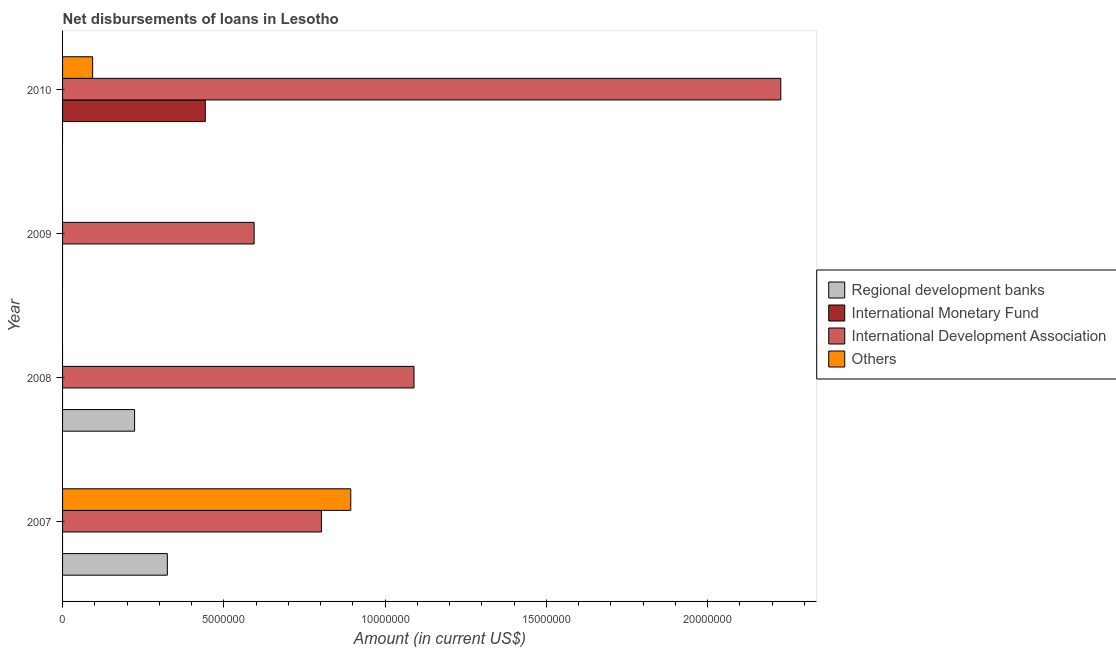How many different coloured bars are there?
Your response must be concise. 4. Are the number of bars per tick equal to the number of legend labels?
Make the answer very short. No. Are the number of bars on each tick of the Y-axis equal?
Offer a very short reply. No. How many bars are there on the 1st tick from the bottom?
Your answer should be very brief. 3. What is the amount of loan disimbursed by international development association in 2008?
Offer a very short reply. 1.09e+07. Across all years, what is the maximum amount of loan disimbursed by regional development banks?
Your answer should be compact. 3.25e+06. In which year was the amount of loan disimbursed by other organisations maximum?
Give a very brief answer. 2007. What is the total amount of loan disimbursed by regional development banks in the graph?
Offer a very short reply. 5.48e+06. What is the difference between the amount of loan disimbursed by international development association in 2007 and that in 2010?
Provide a short and direct response. -1.42e+07. What is the difference between the amount of loan disimbursed by international monetary fund in 2008 and the amount of loan disimbursed by regional development banks in 2007?
Your response must be concise. -3.25e+06. What is the average amount of loan disimbursed by other organisations per year?
Your answer should be compact. 2.47e+06. In the year 2010, what is the difference between the amount of loan disimbursed by international development association and amount of loan disimbursed by other organisations?
Give a very brief answer. 2.13e+07. What is the difference between the highest and the second highest amount of loan disimbursed by international development association?
Your answer should be compact. 1.14e+07. What is the difference between the highest and the lowest amount of loan disimbursed by other organisations?
Your response must be concise. 8.94e+06. Is it the case that in every year, the sum of the amount of loan disimbursed by international monetary fund and amount of loan disimbursed by regional development banks is greater than the sum of amount of loan disimbursed by international development association and amount of loan disimbursed by other organisations?
Keep it short and to the point. No. How many years are there in the graph?
Your answer should be compact. 4. Does the graph contain any zero values?
Make the answer very short. Yes. Does the graph contain grids?
Keep it short and to the point. No. How many legend labels are there?
Provide a short and direct response. 4. What is the title of the graph?
Your answer should be compact. Net disbursements of loans in Lesotho. Does "Negligence towards children" appear as one of the legend labels in the graph?
Make the answer very short. No. What is the Amount (in current US$) of Regional development banks in 2007?
Offer a very short reply. 3.25e+06. What is the Amount (in current US$) in International Monetary Fund in 2007?
Keep it short and to the point. 0. What is the Amount (in current US$) in International Development Association in 2007?
Ensure brevity in your answer.  8.02e+06. What is the Amount (in current US$) in Others in 2007?
Your response must be concise. 8.94e+06. What is the Amount (in current US$) in Regional development banks in 2008?
Offer a very short reply. 2.23e+06. What is the Amount (in current US$) in International Development Association in 2008?
Offer a terse response. 1.09e+07. What is the Amount (in current US$) in Regional development banks in 2009?
Your answer should be compact. 0. What is the Amount (in current US$) of International Development Association in 2009?
Provide a short and direct response. 5.94e+06. What is the Amount (in current US$) in Regional development banks in 2010?
Keep it short and to the point. 0. What is the Amount (in current US$) of International Monetary Fund in 2010?
Ensure brevity in your answer.  4.42e+06. What is the Amount (in current US$) in International Development Association in 2010?
Provide a succinct answer. 2.23e+07. What is the Amount (in current US$) in Others in 2010?
Your response must be concise. 9.32e+05. Across all years, what is the maximum Amount (in current US$) of Regional development banks?
Your answer should be compact. 3.25e+06. Across all years, what is the maximum Amount (in current US$) in International Monetary Fund?
Your response must be concise. 4.42e+06. Across all years, what is the maximum Amount (in current US$) in International Development Association?
Offer a very short reply. 2.23e+07. Across all years, what is the maximum Amount (in current US$) of Others?
Give a very brief answer. 8.94e+06. Across all years, what is the minimum Amount (in current US$) in Regional development banks?
Give a very brief answer. 0. Across all years, what is the minimum Amount (in current US$) in International Monetary Fund?
Offer a terse response. 0. Across all years, what is the minimum Amount (in current US$) of International Development Association?
Provide a succinct answer. 5.94e+06. What is the total Amount (in current US$) in Regional development banks in the graph?
Provide a short and direct response. 5.48e+06. What is the total Amount (in current US$) in International Monetary Fund in the graph?
Your answer should be compact. 4.42e+06. What is the total Amount (in current US$) of International Development Association in the graph?
Your answer should be compact. 4.71e+07. What is the total Amount (in current US$) of Others in the graph?
Offer a very short reply. 9.87e+06. What is the difference between the Amount (in current US$) in Regional development banks in 2007 and that in 2008?
Provide a succinct answer. 1.02e+06. What is the difference between the Amount (in current US$) of International Development Association in 2007 and that in 2008?
Provide a succinct answer. -2.87e+06. What is the difference between the Amount (in current US$) of International Development Association in 2007 and that in 2009?
Give a very brief answer. 2.09e+06. What is the difference between the Amount (in current US$) of International Development Association in 2007 and that in 2010?
Your answer should be very brief. -1.42e+07. What is the difference between the Amount (in current US$) in Others in 2007 and that in 2010?
Offer a very short reply. 8.00e+06. What is the difference between the Amount (in current US$) in International Development Association in 2008 and that in 2009?
Make the answer very short. 4.96e+06. What is the difference between the Amount (in current US$) in International Development Association in 2008 and that in 2010?
Give a very brief answer. -1.14e+07. What is the difference between the Amount (in current US$) in International Development Association in 2009 and that in 2010?
Ensure brevity in your answer.  -1.63e+07. What is the difference between the Amount (in current US$) in Regional development banks in 2007 and the Amount (in current US$) in International Development Association in 2008?
Offer a terse response. -7.65e+06. What is the difference between the Amount (in current US$) in Regional development banks in 2007 and the Amount (in current US$) in International Development Association in 2009?
Your answer should be very brief. -2.69e+06. What is the difference between the Amount (in current US$) of Regional development banks in 2007 and the Amount (in current US$) of International Monetary Fund in 2010?
Keep it short and to the point. -1.18e+06. What is the difference between the Amount (in current US$) in Regional development banks in 2007 and the Amount (in current US$) in International Development Association in 2010?
Your answer should be compact. -1.90e+07. What is the difference between the Amount (in current US$) of Regional development banks in 2007 and the Amount (in current US$) of Others in 2010?
Your answer should be compact. 2.32e+06. What is the difference between the Amount (in current US$) in International Development Association in 2007 and the Amount (in current US$) in Others in 2010?
Make the answer very short. 7.09e+06. What is the difference between the Amount (in current US$) in Regional development banks in 2008 and the Amount (in current US$) in International Development Association in 2009?
Your response must be concise. -3.71e+06. What is the difference between the Amount (in current US$) in Regional development banks in 2008 and the Amount (in current US$) in International Monetary Fund in 2010?
Your response must be concise. -2.19e+06. What is the difference between the Amount (in current US$) of Regional development banks in 2008 and the Amount (in current US$) of International Development Association in 2010?
Provide a succinct answer. -2.00e+07. What is the difference between the Amount (in current US$) in Regional development banks in 2008 and the Amount (in current US$) in Others in 2010?
Provide a short and direct response. 1.30e+06. What is the difference between the Amount (in current US$) in International Development Association in 2008 and the Amount (in current US$) in Others in 2010?
Your answer should be very brief. 9.96e+06. What is the difference between the Amount (in current US$) of International Development Association in 2009 and the Amount (in current US$) of Others in 2010?
Make the answer very short. 5.01e+06. What is the average Amount (in current US$) in Regional development banks per year?
Give a very brief answer. 1.37e+06. What is the average Amount (in current US$) of International Monetary Fund per year?
Your response must be concise. 1.11e+06. What is the average Amount (in current US$) in International Development Association per year?
Your answer should be very brief. 1.18e+07. What is the average Amount (in current US$) of Others per year?
Provide a succinct answer. 2.47e+06. In the year 2007, what is the difference between the Amount (in current US$) of Regional development banks and Amount (in current US$) of International Development Association?
Your answer should be very brief. -4.78e+06. In the year 2007, what is the difference between the Amount (in current US$) of Regional development banks and Amount (in current US$) of Others?
Your answer should be compact. -5.69e+06. In the year 2007, what is the difference between the Amount (in current US$) in International Development Association and Amount (in current US$) in Others?
Keep it short and to the point. -9.10e+05. In the year 2008, what is the difference between the Amount (in current US$) in Regional development banks and Amount (in current US$) in International Development Association?
Provide a short and direct response. -8.66e+06. In the year 2010, what is the difference between the Amount (in current US$) of International Monetary Fund and Amount (in current US$) of International Development Association?
Offer a very short reply. -1.78e+07. In the year 2010, what is the difference between the Amount (in current US$) in International Monetary Fund and Amount (in current US$) in Others?
Your response must be concise. 3.49e+06. In the year 2010, what is the difference between the Amount (in current US$) of International Development Association and Amount (in current US$) of Others?
Your answer should be compact. 2.13e+07. What is the ratio of the Amount (in current US$) of Regional development banks in 2007 to that in 2008?
Provide a succinct answer. 1.45. What is the ratio of the Amount (in current US$) in International Development Association in 2007 to that in 2008?
Offer a very short reply. 0.74. What is the ratio of the Amount (in current US$) of International Development Association in 2007 to that in 2009?
Offer a terse response. 1.35. What is the ratio of the Amount (in current US$) in International Development Association in 2007 to that in 2010?
Your response must be concise. 0.36. What is the ratio of the Amount (in current US$) of Others in 2007 to that in 2010?
Keep it short and to the point. 9.59. What is the ratio of the Amount (in current US$) in International Development Association in 2008 to that in 2009?
Your answer should be very brief. 1.83. What is the ratio of the Amount (in current US$) of International Development Association in 2008 to that in 2010?
Offer a very short reply. 0.49. What is the ratio of the Amount (in current US$) in International Development Association in 2009 to that in 2010?
Provide a short and direct response. 0.27. What is the difference between the highest and the second highest Amount (in current US$) of International Development Association?
Keep it short and to the point. 1.14e+07. What is the difference between the highest and the lowest Amount (in current US$) of Regional development banks?
Provide a short and direct response. 3.25e+06. What is the difference between the highest and the lowest Amount (in current US$) of International Monetary Fund?
Offer a very short reply. 4.42e+06. What is the difference between the highest and the lowest Amount (in current US$) in International Development Association?
Your answer should be very brief. 1.63e+07. What is the difference between the highest and the lowest Amount (in current US$) of Others?
Provide a succinct answer. 8.94e+06. 